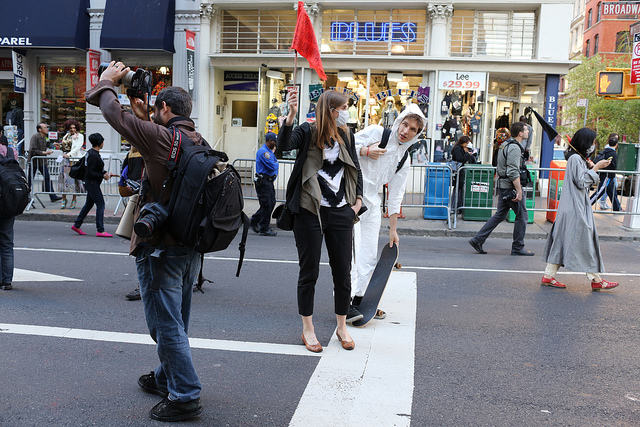Please transcribe the text in this image. BLUES 29.99 BROADW 